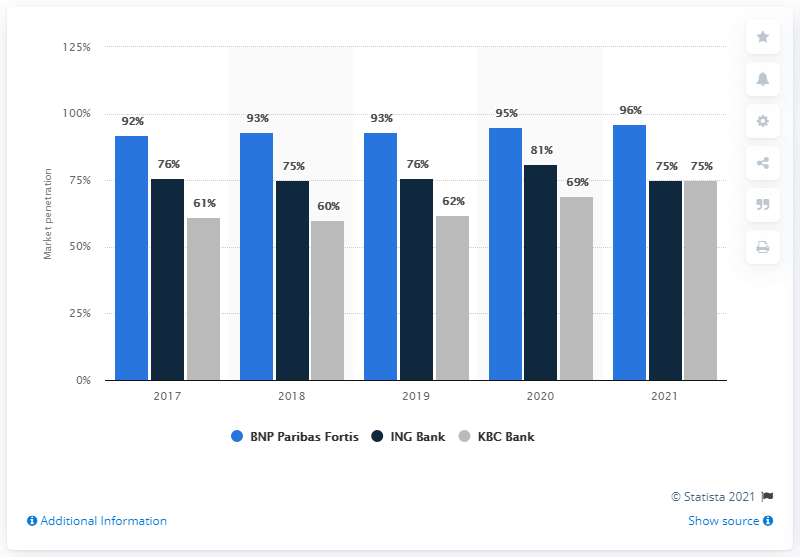Point out several critical features in this image. According to a survey of financial officers, 96% believed the Belgian daughter of BNP Paribas to be an essential provider of corporate banking services. BNP Paribas Fortis achieved the highest corporate banking market penetration of banks in 2021. 